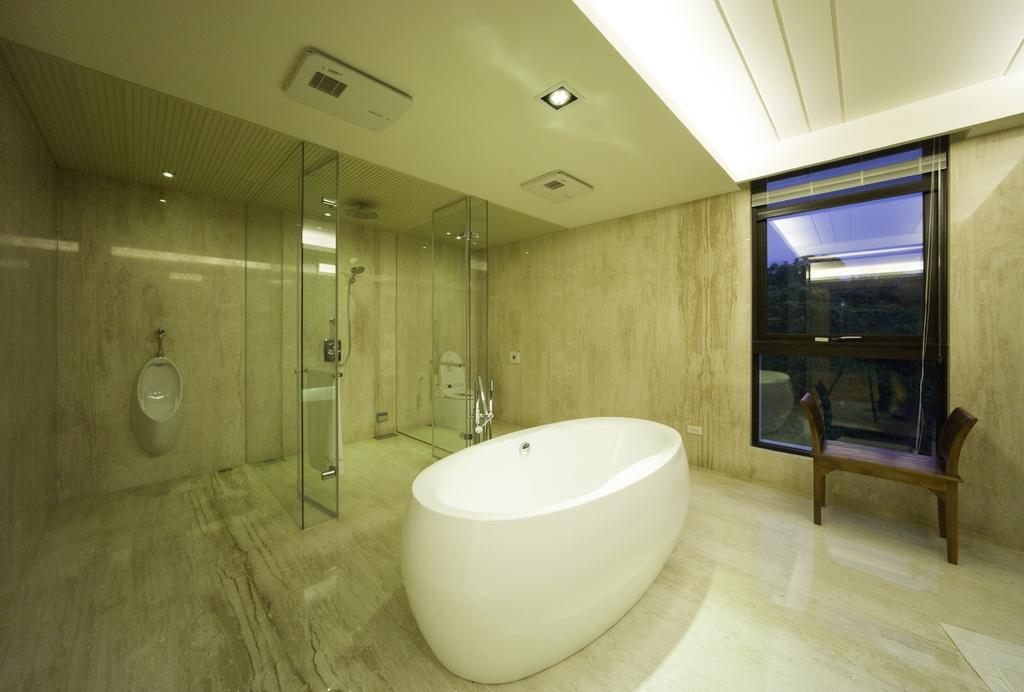What is located on the floor in the image? There is a bathtub on the floor in the image. What type of furniture is present in the image? There is a bench in the image. What type of plumbing fixture can be seen in the image? There are toilets in the image. What type of architectural elements are present in the image? The image contains walls and a ceiling. What type of opening is present in the walls? There is a window in the image. What type of objects are present in the image? There are objects in the image. What type of natural scenery is visible in the background of the image? Trees and the sky are visible in the background of the image. What type of butter is being used to treat the patients in the hospital in the image? There is no hospital or butter present in the image. What type of berry is being used to decorate the room in the image? There is no berry present in the image. 